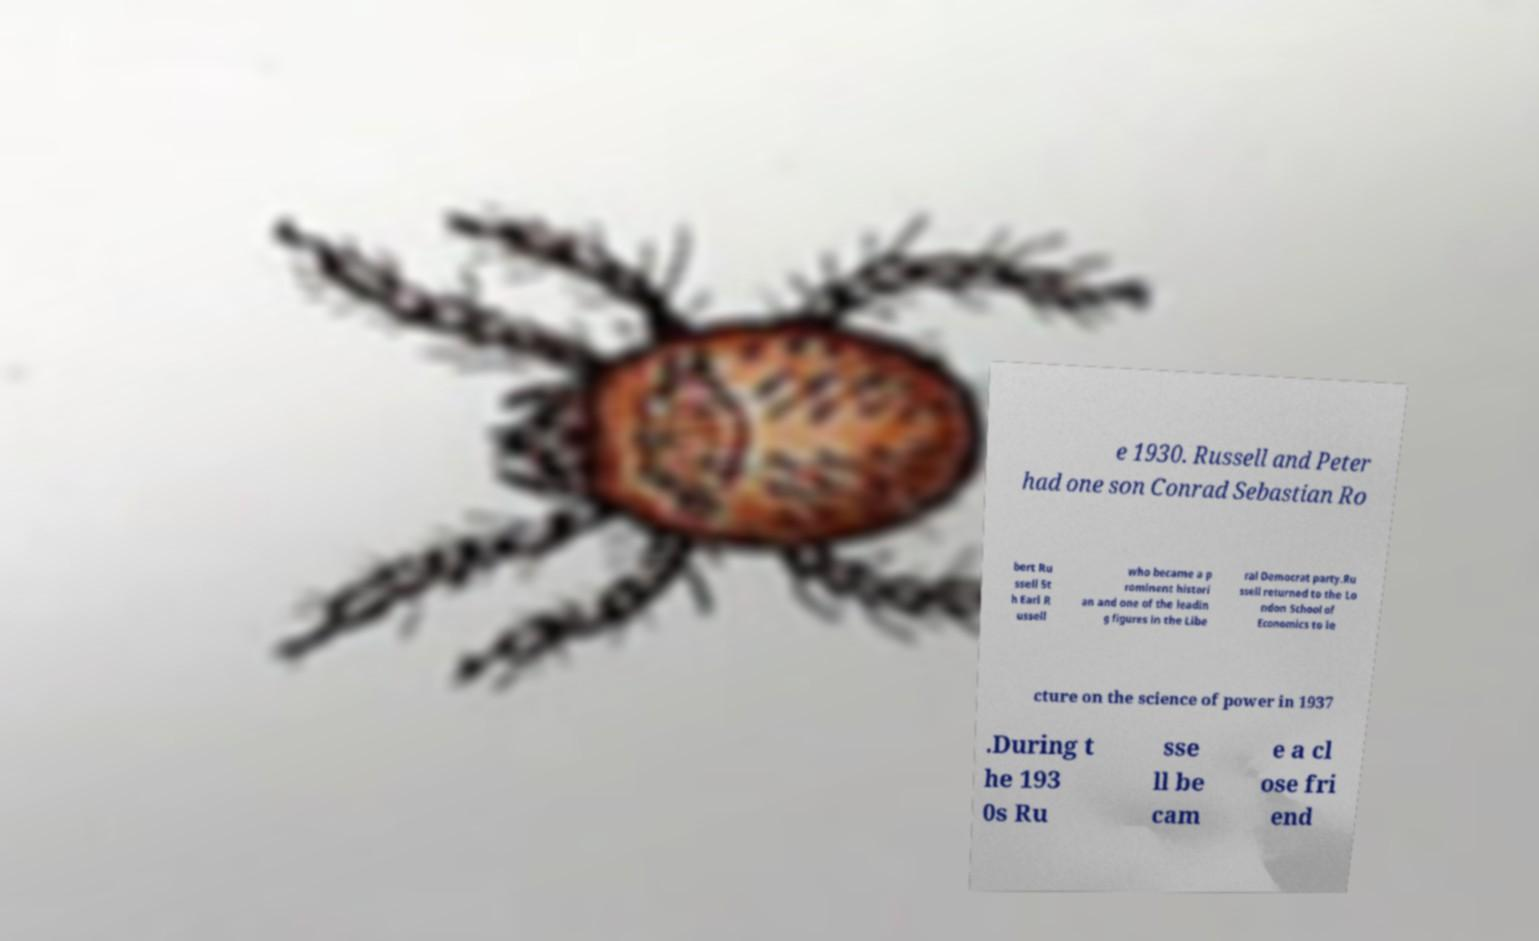Could you assist in decoding the text presented in this image and type it out clearly? e 1930. Russell and Peter had one son Conrad Sebastian Ro bert Ru ssell 5t h Earl R ussell who became a p rominent histori an and one of the leadin g figures in the Libe ral Democrat party.Ru ssell returned to the Lo ndon School of Economics to le cture on the science of power in 1937 .During t he 193 0s Ru sse ll be cam e a cl ose fri end 